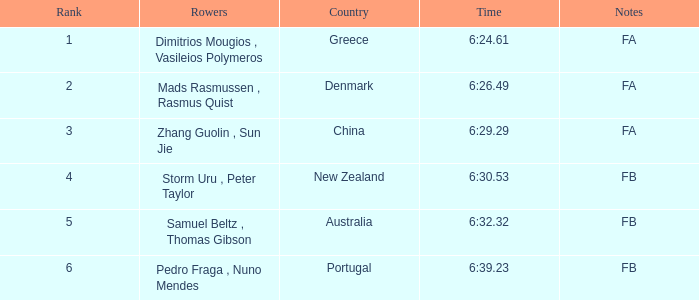What are the appellations of the rowers whose duration was 6:2 Dimitrios Mougios , Vasileios Polymeros. 